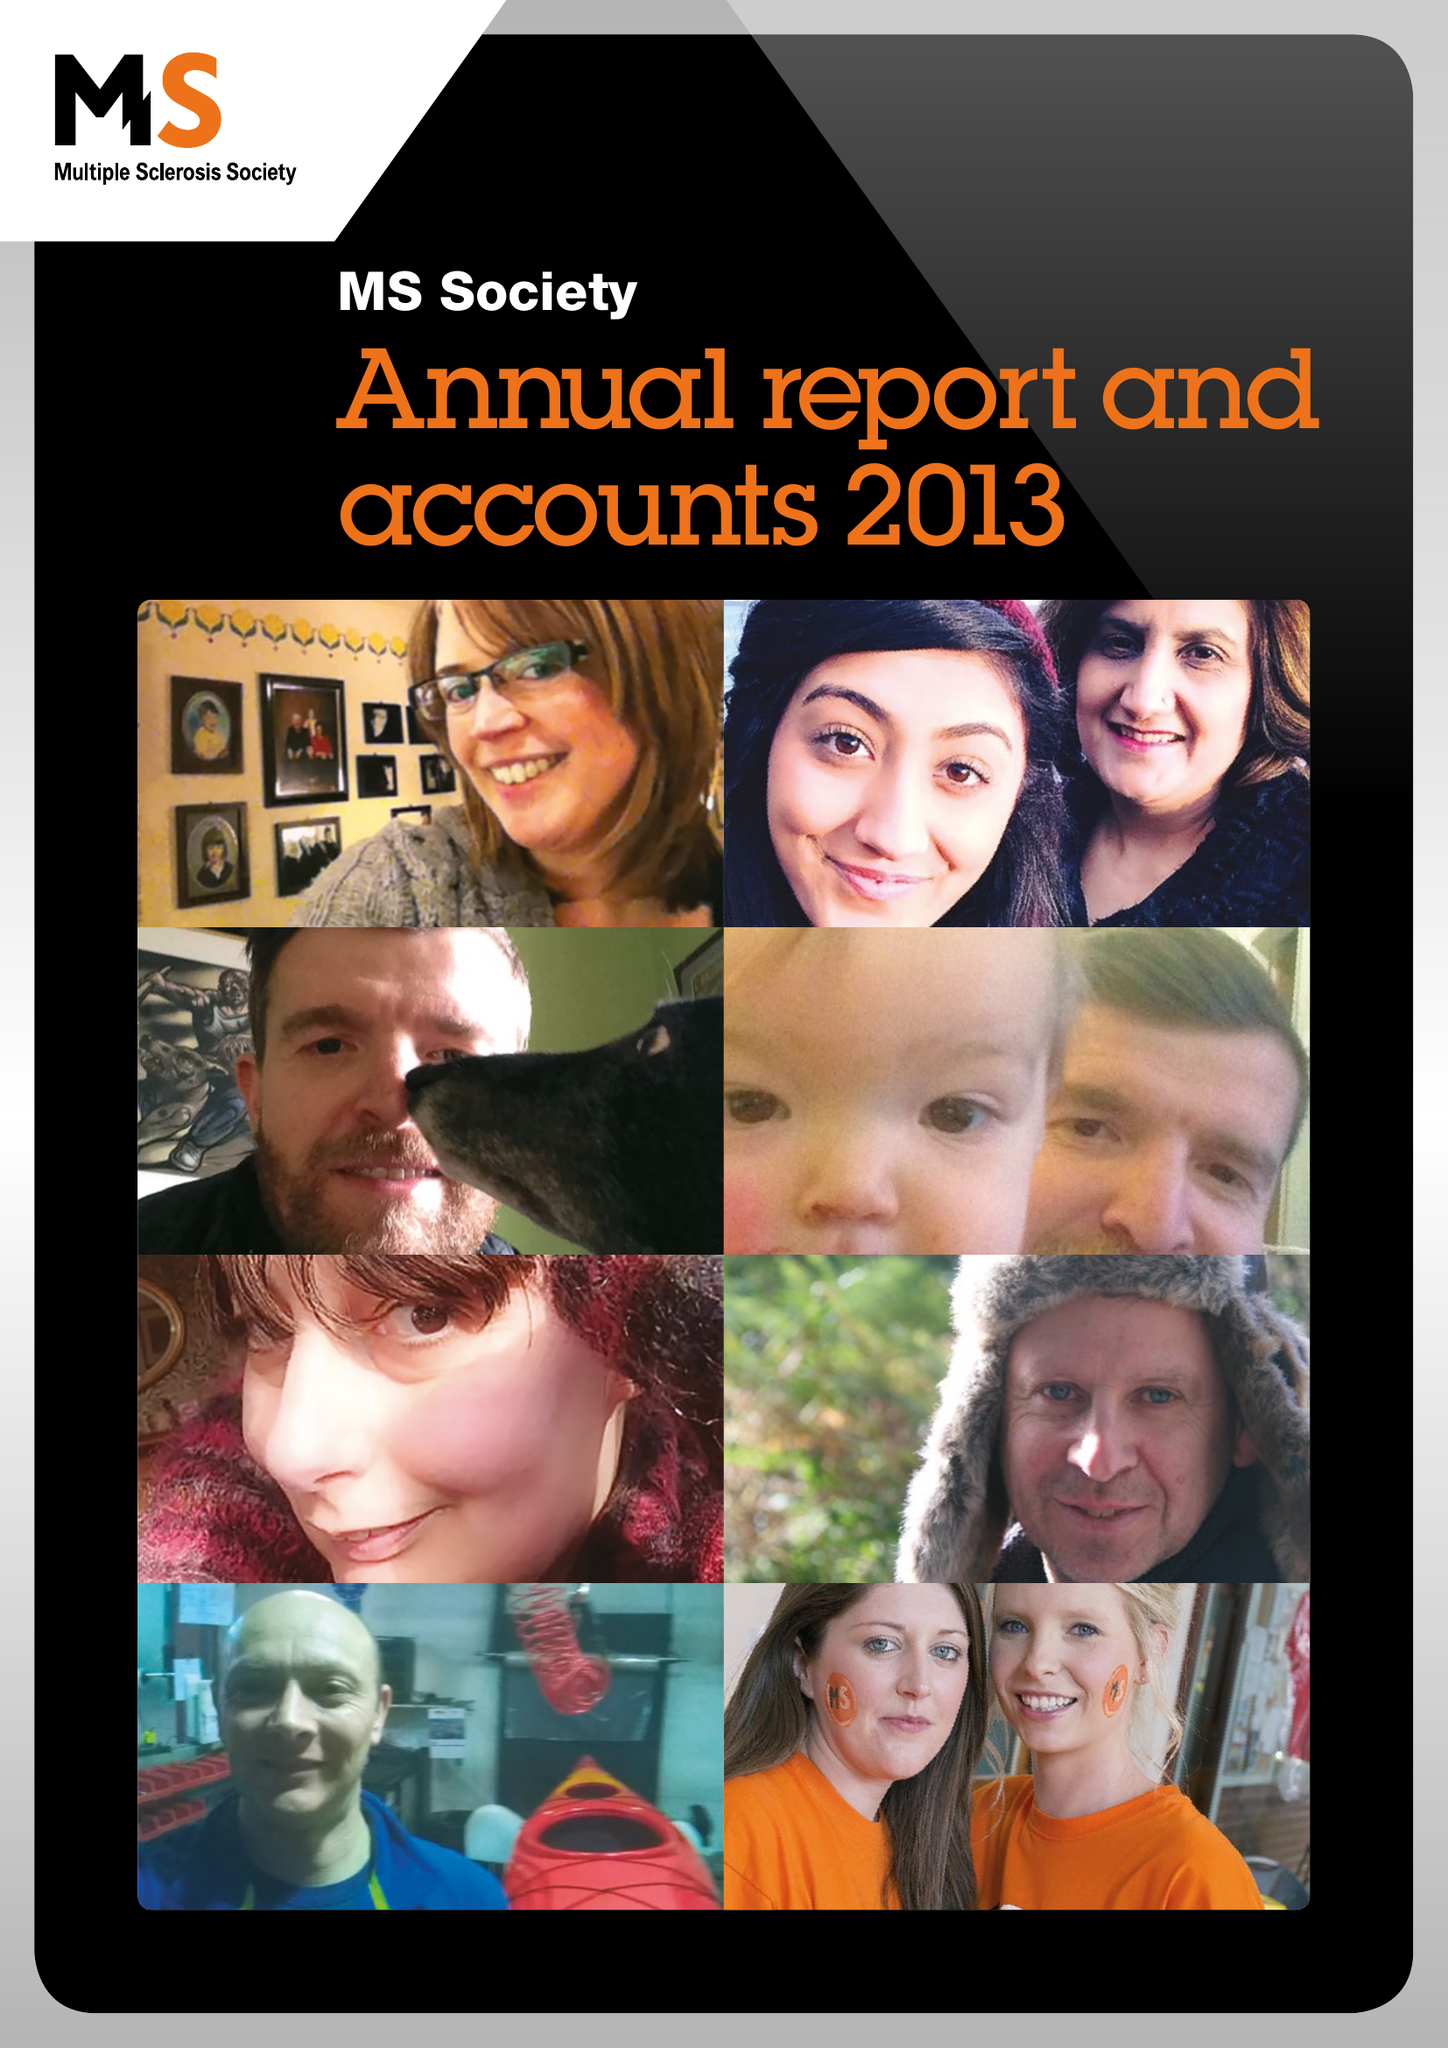What is the value for the address__street_line?
Answer the question using a single word or phrase. 372 EDGWARE ROAD 